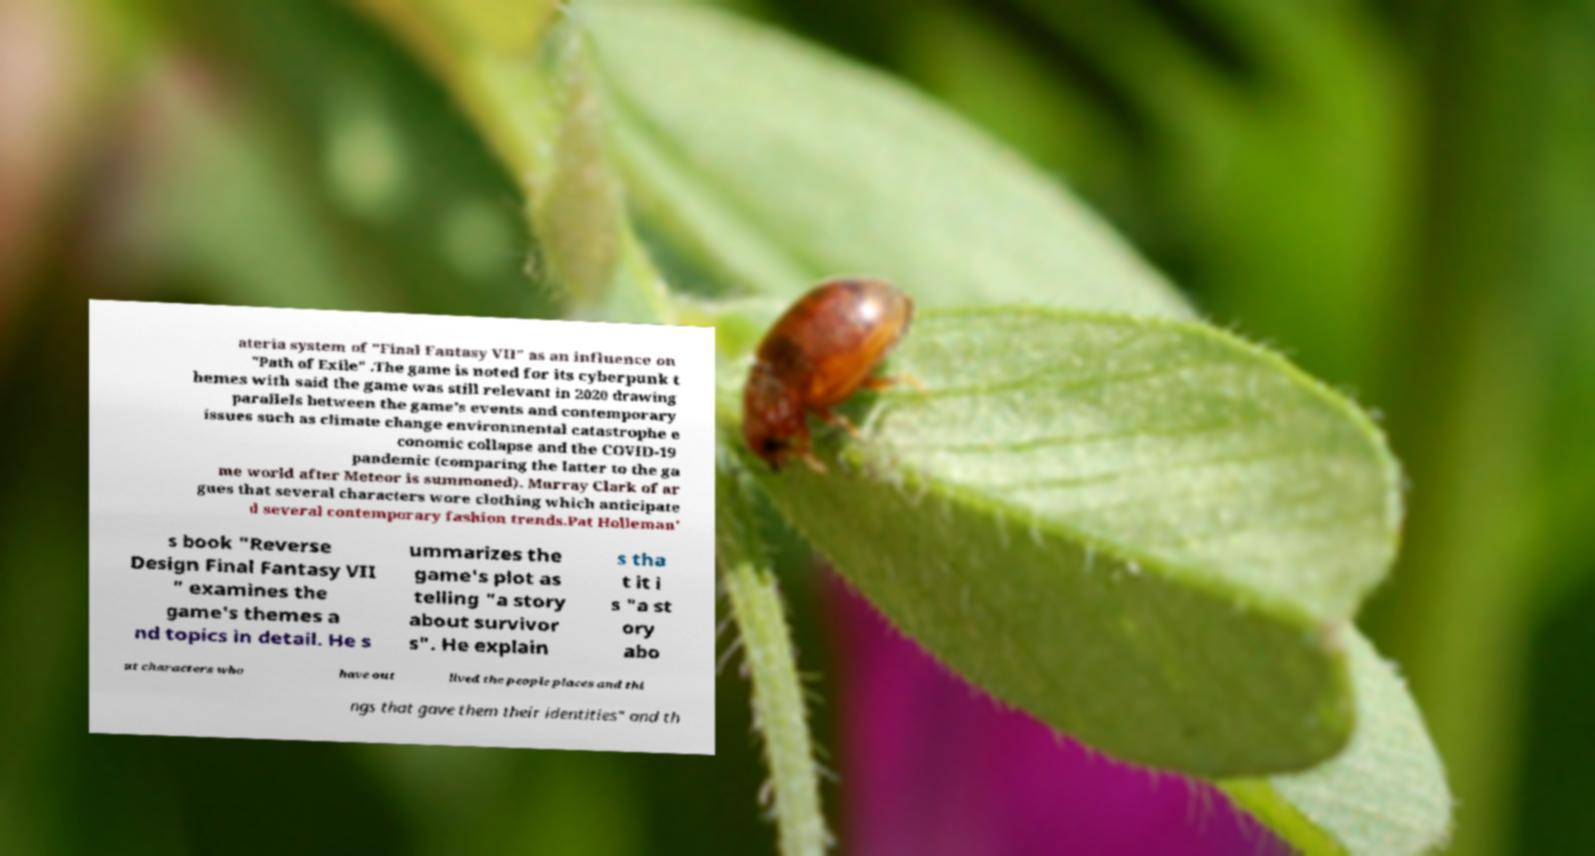Could you assist in decoding the text presented in this image and type it out clearly? ateria system of "Final Fantasy VII" as an influence on "Path of Exile" .The game is noted for its cyberpunk t hemes with said the game was still relevant in 2020 drawing parallels between the game's events and contemporary issues such as climate change environmental catastrophe e conomic collapse and the COVID-19 pandemic (comparing the latter to the ga me world after Meteor is summoned). Murray Clark of ar gues that several characters wore clothing which anticipate d several contemporary fashion trends.Pat Holleman' s book "Reverse Design Final Fantasy VII " examines the game's themes a nd topics in detail. He s ummarizes the game's plot as telling "a story about survivor s". He explain s tha t it i s "a st ory abo ut characters who have out lived the people places and thi ngs that gave them their identities" and th 